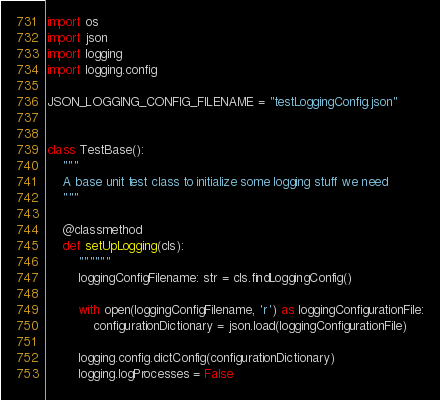<code> <loc_0><loc_0><loc_500><loc_500><_Python_>
import os
import json
import logging
import logging.config

JSON_LOGGING_CONFIG_FILENAME = "testLoggingConfig.json"


class TestBase():
    """
    A base unit test class to initialize some logging stuff we need
    """

    @classmethod
    def setUpLogging(cls):
        """"""
        loggingConfigFilename: str = cls.findLoggingConfig()

        with open(loggingConfigFilename, 'r') as loggingConfigurationFile:
            configurationDictionary = json.load(loggingConfigurationFile)

        logging.config.dictConfig(configurationDictionary)
        logging.logProcesses = False</code> 